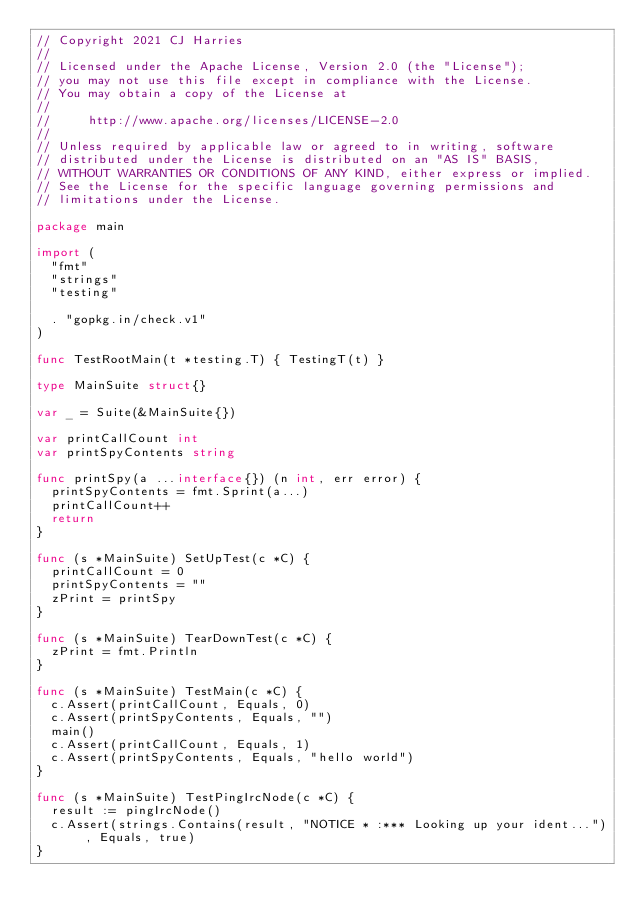<code> <loc_0><loc_0><loc_500><loc_500><_Go_>// Copyright 2021 CJ Harries
//
// Licensed under the Apache License, Version 2.0 (the "License");
// you may not use this file except in compliance with the License.
// You may obtain a copy of the License at
//
//     http://www.apache.org/licenses/LICENSE-2.0
//
// Unless required by applicable law or agreed to in writing, software
// distributed under the License is distributed on an "AS IS" BASIS,
// WITHOUT WARRANTIES OR CONDITIONS OF ANY KIND, either express or implied.
// See the License for the specific language governing permissions and
// limitations under the License.

package main

import (
	"fmt"
	"strings"
	"testing"

	. "gopkg.in/check.v1"
)

func TestRootMain(t *testing.T) { TestingT(t) }

type MainSuite struct{}

var _ = Suite(&MainSuite{})

var printCallCount int
var printSpyContents string

func printSpy(a ...interface{}) (n int, err error) {
	printSpyContents = fmt.Sprint(a...)
	printCallCount++
	return
}

func (s *MainSuite) SetUpTest(c *C) {
	printCallCount = 0
	printSpyContents = ""
	zPrint = printSpy
}

func (s *MainSuite) TearDownTest(c *C) {
	zPrint = fmt.Println
}

func (s *MainSuite) TestMain(c *C) {
	c.Assert(printCallCount, Equals, 0)
	c.Assert(printSpyContents, Equals, "")
	main()
	c.Assert(printCallCount, Equals, 1)
	c.Assert(printSpyContents, Equals, "hello world")
}

func (s *MainSuite) TestPingIrcNode(c *C) {
	result := pingIrcNode()
	c.Assert(strings.Contains(result, "NOTICE * :*** Looking up your ident..."), Equals, true)
}
</code> 